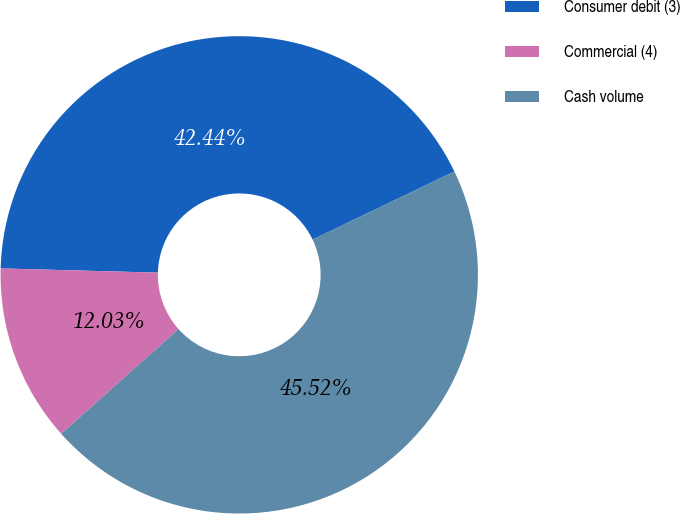Convert chart. <chart><loc_0><loc_0><loc_500><loc_500><pie_chart><fcel>Consumer debit (3)<fcel>Commercial (4)<fcel>Cash volume<nl><fcel>42.44%<fcel>12.03%<fcel>45.52%<nl></chart> 